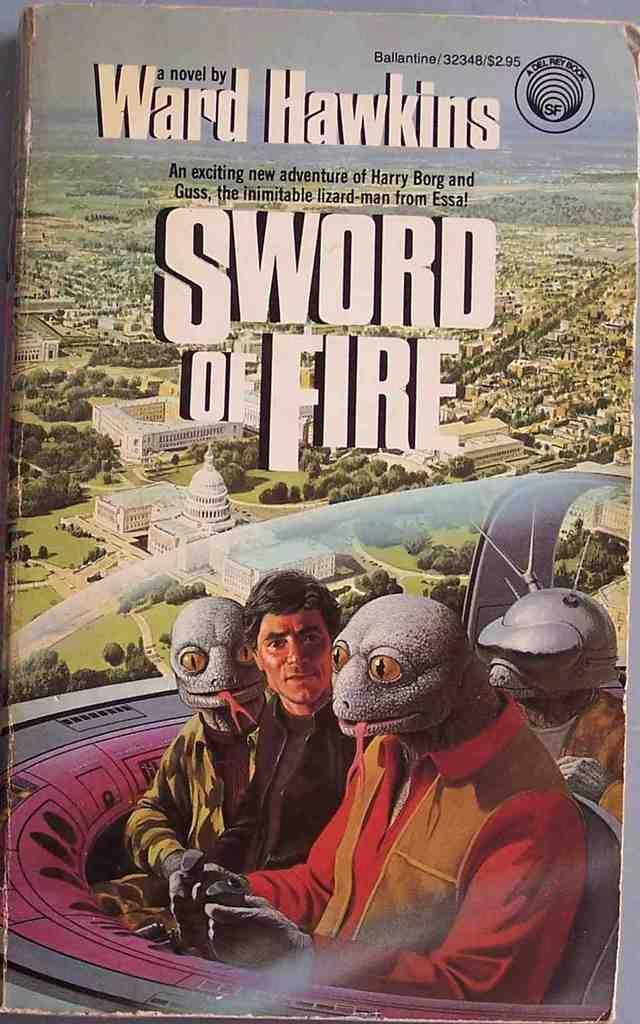What is the main subject of the image? The main subject of the image is the cover page of a book. What can be seen on the cover page? There are images and text on the cover page. How does the horse on the cover page compare to the other animals in the image? There is no horse present on the cover page, as the image only contains images and text related to the book. 